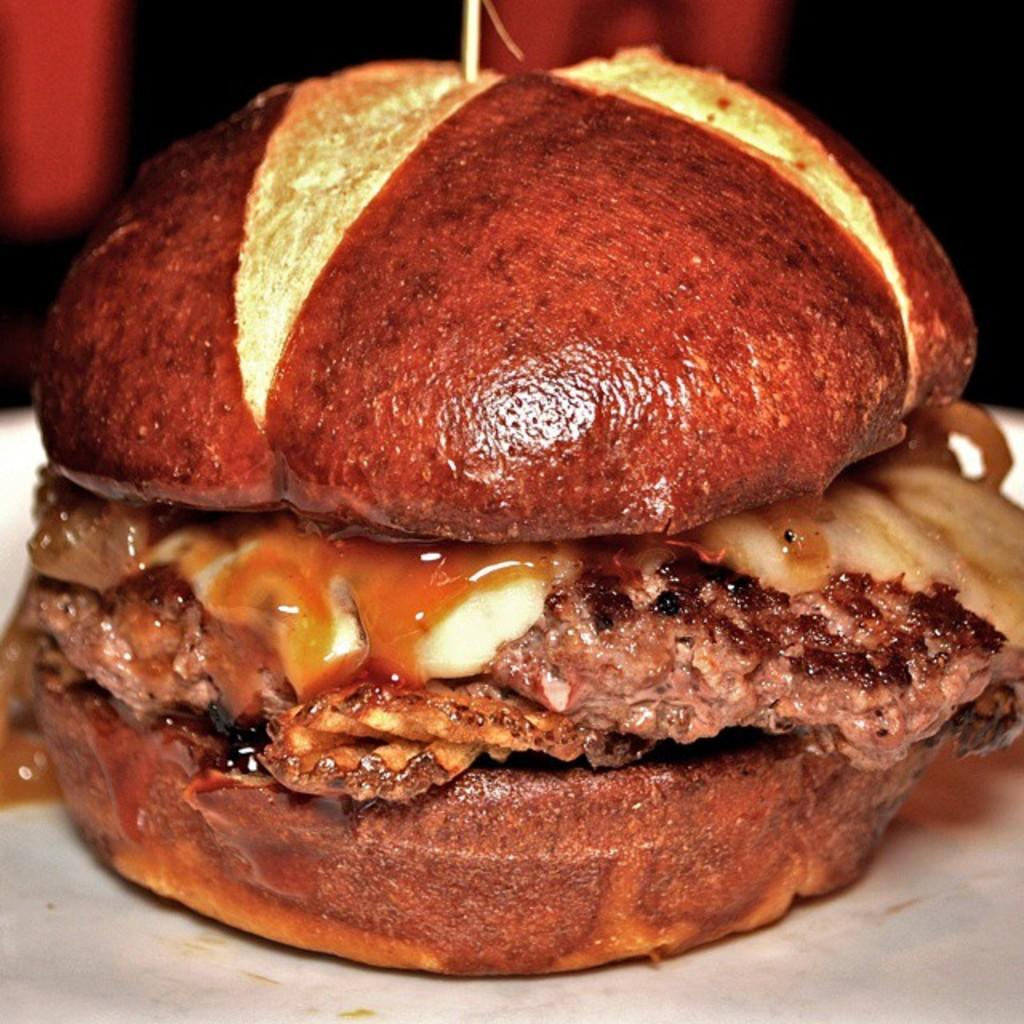What type of food is visible in the image? There is a burger in the image. Can you describe the background of the image? The background of the image is blurred. On what surface is the burger placed? The burger is placed on a white surface. What is the doctor doing in the image? There is no doctor present in the image; it features a burger on a white surface with a blurred background. 